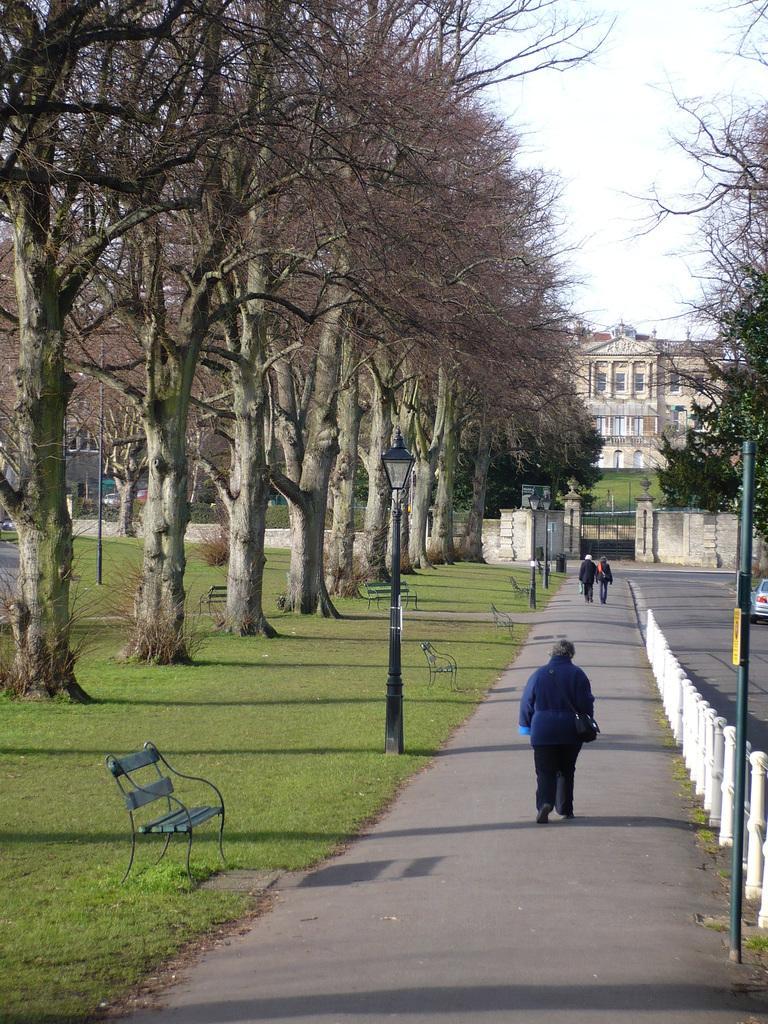How would you summarize this image in a sentence or two? In this image I can see few people walking on the road. I can see lights-poles,benches,trees and fencing. Back I can see a building and windows. The sky is in white color. 